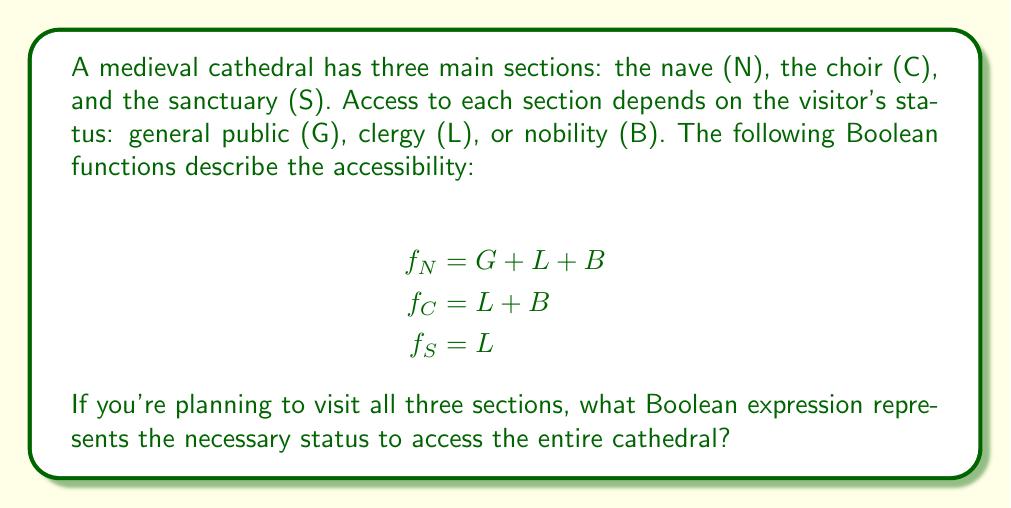Give your solution to this math problem. To access all three sections of the cathedral, a visitor must satisfy the conditions for each section simultaneously. This can be represented by the logical AND (∧) of the three Boolean functions:

$$f_{total} = f_N \wedge f_C \wedge f_S$$

Let's substitute the given functions:

$$f_{total} = (G + L + B) \wedge (L + B) \wedge L$$

Simplifying from right to left:

1) $(L + B) \wedge L = L$ (because $L$ is common and more restrictive)

   So, we have: $f_{total} = (G + L + B) \wedge L$

2) $(G + L + B) \wedge L = L$ (because $L$ is common and more restrictive than $G + L + B$)

Therefore, the final simplified expression is:

$$f_{total} = L$$

This means that to access all sections of the cathedral, one must have clergy status (L).
Answer: $L$ 